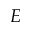<formula> <loc_0><loc_0><loc_500><loc_500>E</formula> 